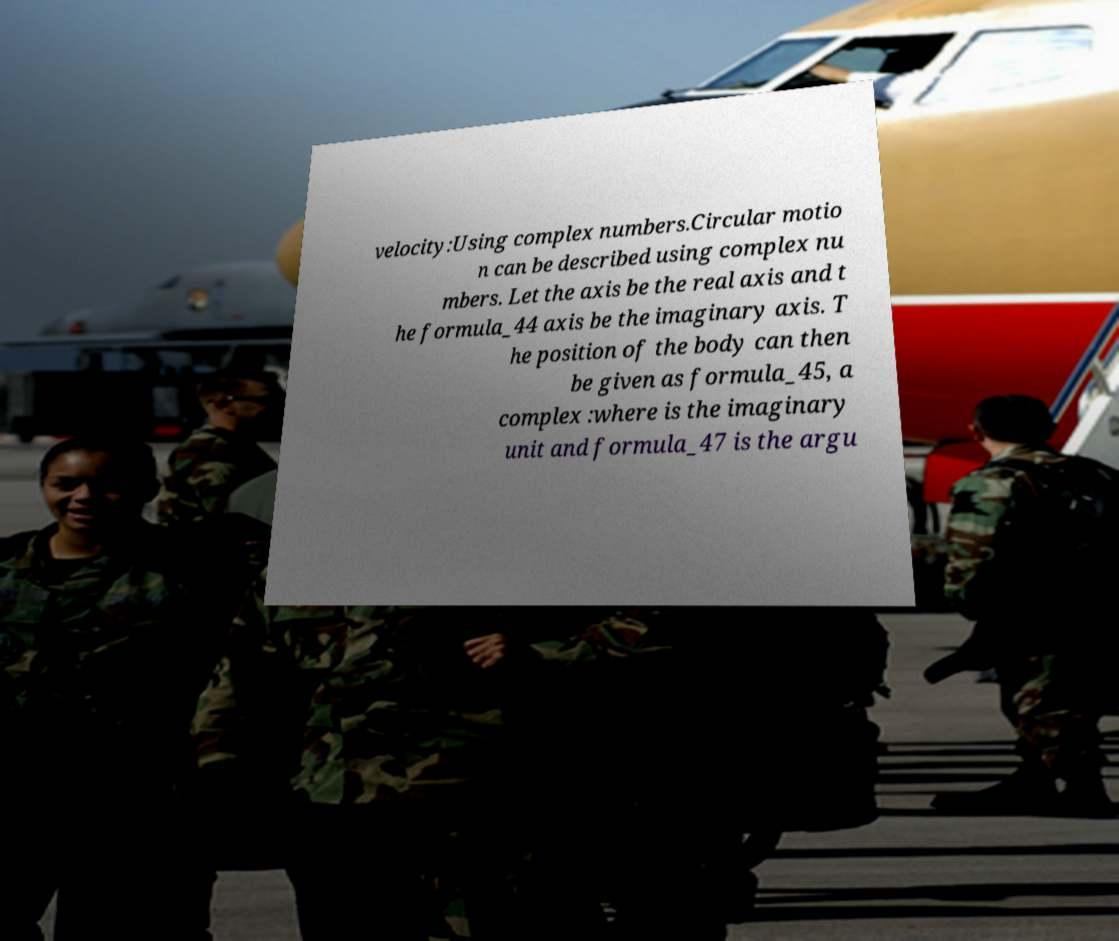Can you read and provide the text displayed in the image?This photo seems to have some interesting text. Can you extract and type it out for me? velocity:Using complex numbers.Circular motio n can be described using complex nu mbers. Let the axis be the real axis and t he formula_44 axis be the imaginary axis. T he position of the body can then be given as formula_45, a complex :where is the imaginary unit and formula_47 is the argu 